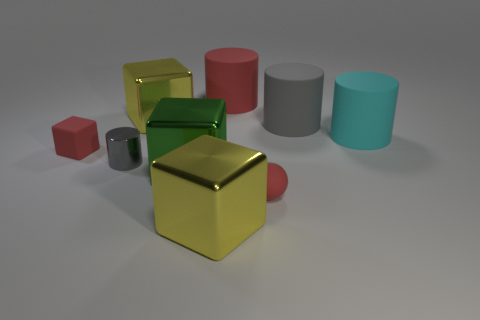What is the texture of the objects like? The objects in the image have a matte, rubbery texture. This can be inferred from the soft reflection and the slight diffusion of light across their surfaces. Could you describe the lighting in the image? The lighting in the image appears to be soft and evenly distributed, with gentle shadows that suggest an overhead diffuse light source, perhaps in a studio setting. 